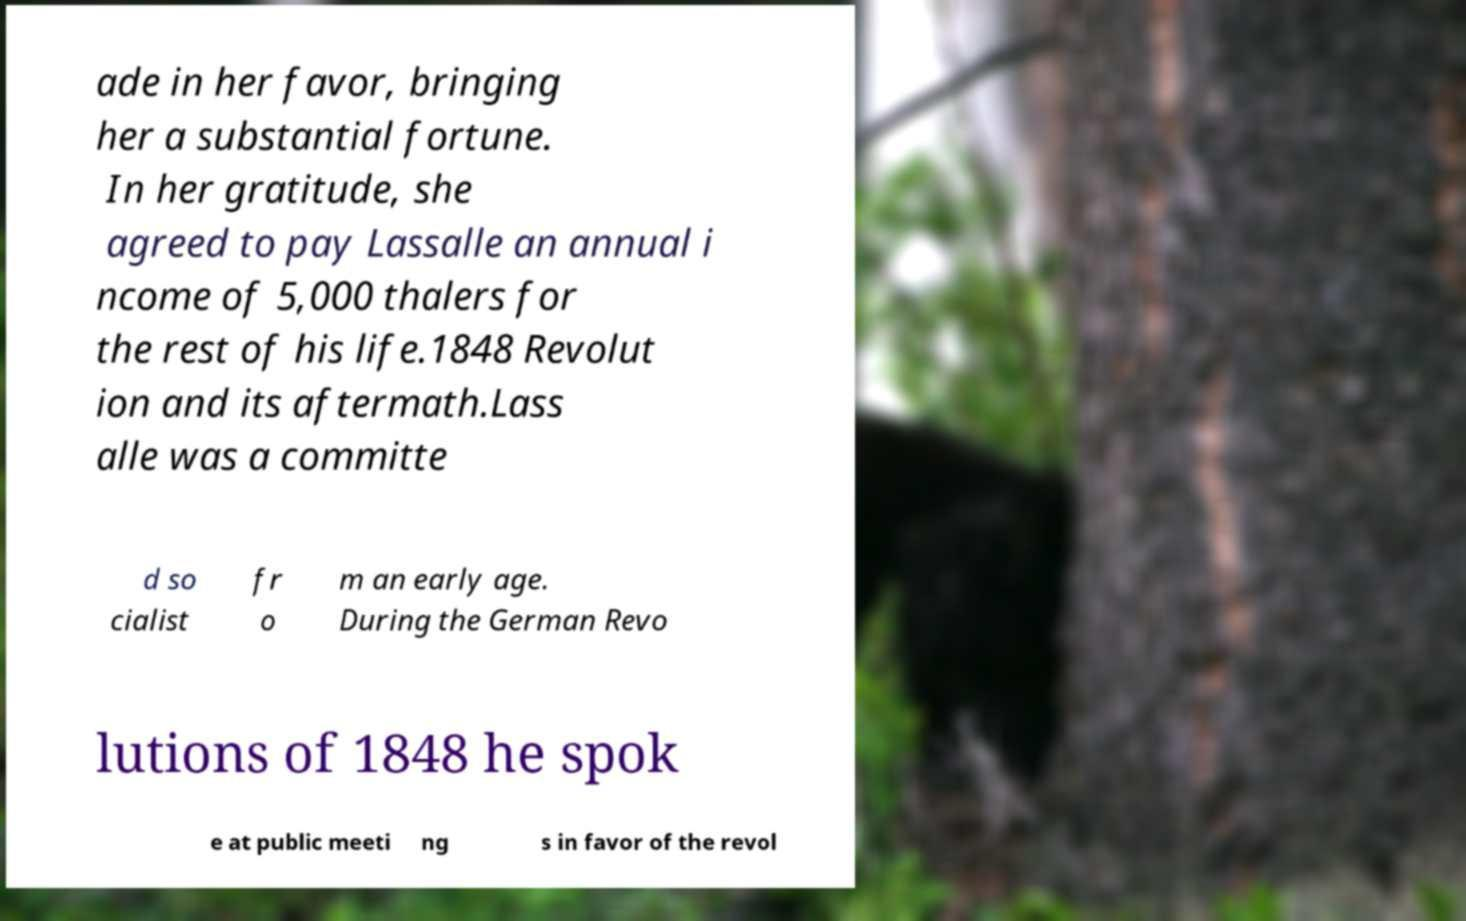There's text embedded in this image that I need extracted. Can you transcribe it verbatim? ade in her favor, bringing her a substantial fortune. In her gratitude, she agreed to pay Lassalle an annual i ncome of 5,000 thalers for the rest of his life.1848 Revolut ion and its aftermath.Lass alle was a committe d so cialist fr o m an early age. During the German Revo lutions of 1848 he spok e at public meeti ng s in favor of the revol 